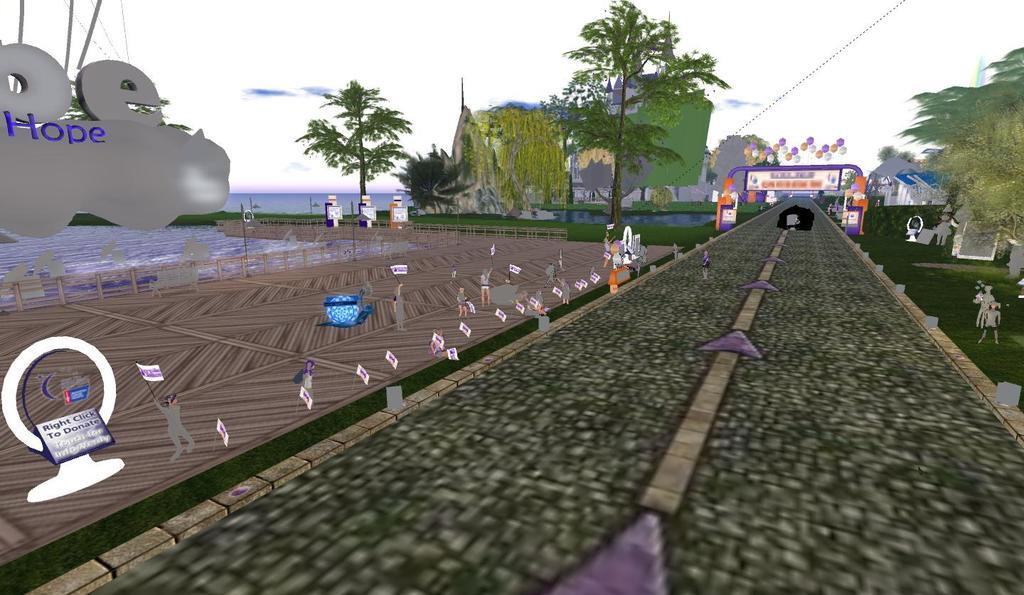What is the main feature of the image? There is a road in the image. Can you describe the people in the image? There is a group of people in the image. What can be seen in the background of the image? There are flags, a platform, objects, trees, a hoarding, balloons, water, a house, and grass visible in the image. What part of the natural environment is visible in the image? Trees, grass, and water are visible in the image. What is the color of the sky in the image? The sky is visible in the image. Where is the cactus located in the image? There is no cactus present in the image. What type of sign can be seen in the image? There is no sign present in the image. 